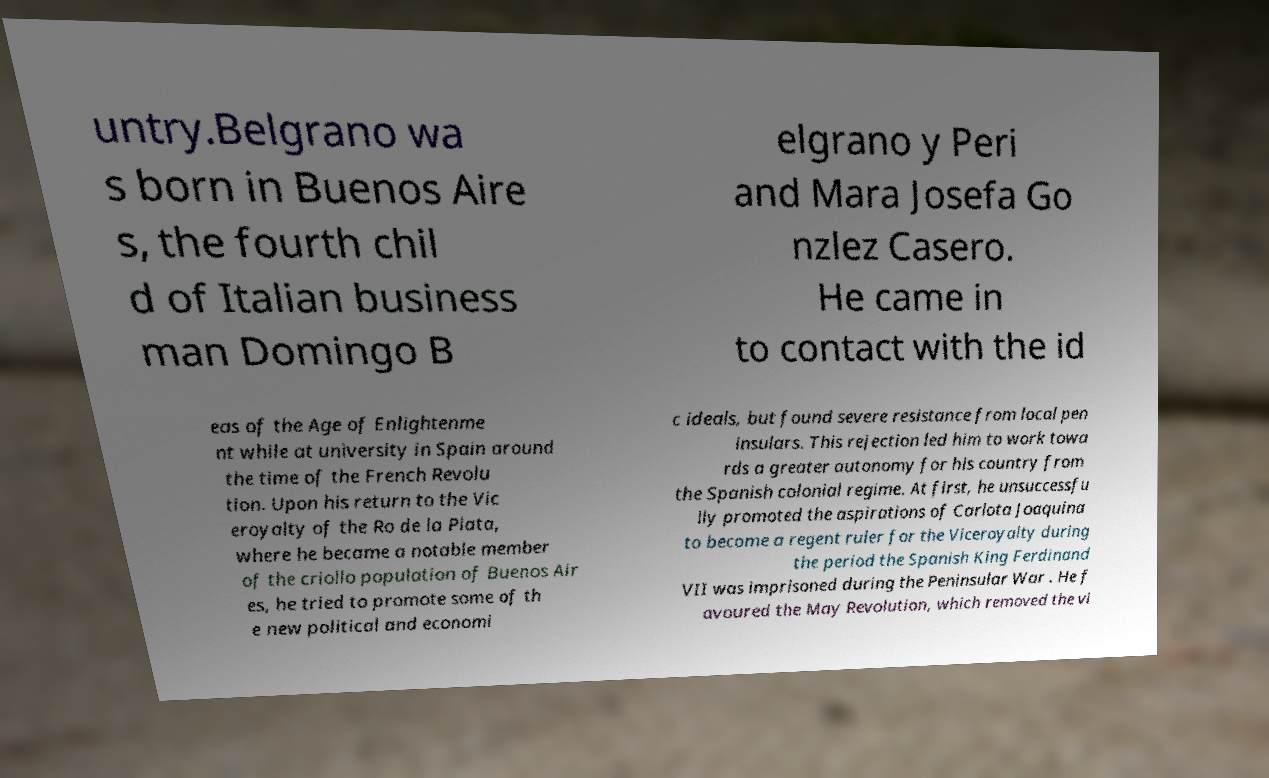Can you read and provide the text displayed in the image?This photo seems to have some interesting text. Can you extract and type it out for me? untry.Belgrano wa s born in Buenos Aire s, the fourth chil d of Italian business man Domingo B elgrano y Peri and Mara Josefa Go nzlez Casero. He came in to contact with the id eas of the Age of Enlightenme nt while at university in Spain around the time of the French Revolu tion. Upon his return to the Vic eroyalty of the Ro de la Plata, where he became a notable member of the criollo population of Buenos Air es, he tried to promote some of th e new political and economi c ideals, but found severe resistance from local pen insulars. This rejection led him to work towa rds a greater autonomy for his country from the Spanish colonial regime. At first, he unsuccessfu lly promoted the aspirations of Carlota Joaquina to become a regent ruler for the Viceroyalty during the period the Spanish King Ferdinand VII was imprisoned during the Peninsular War . He f avoured the May Revolution, which removed the vi 